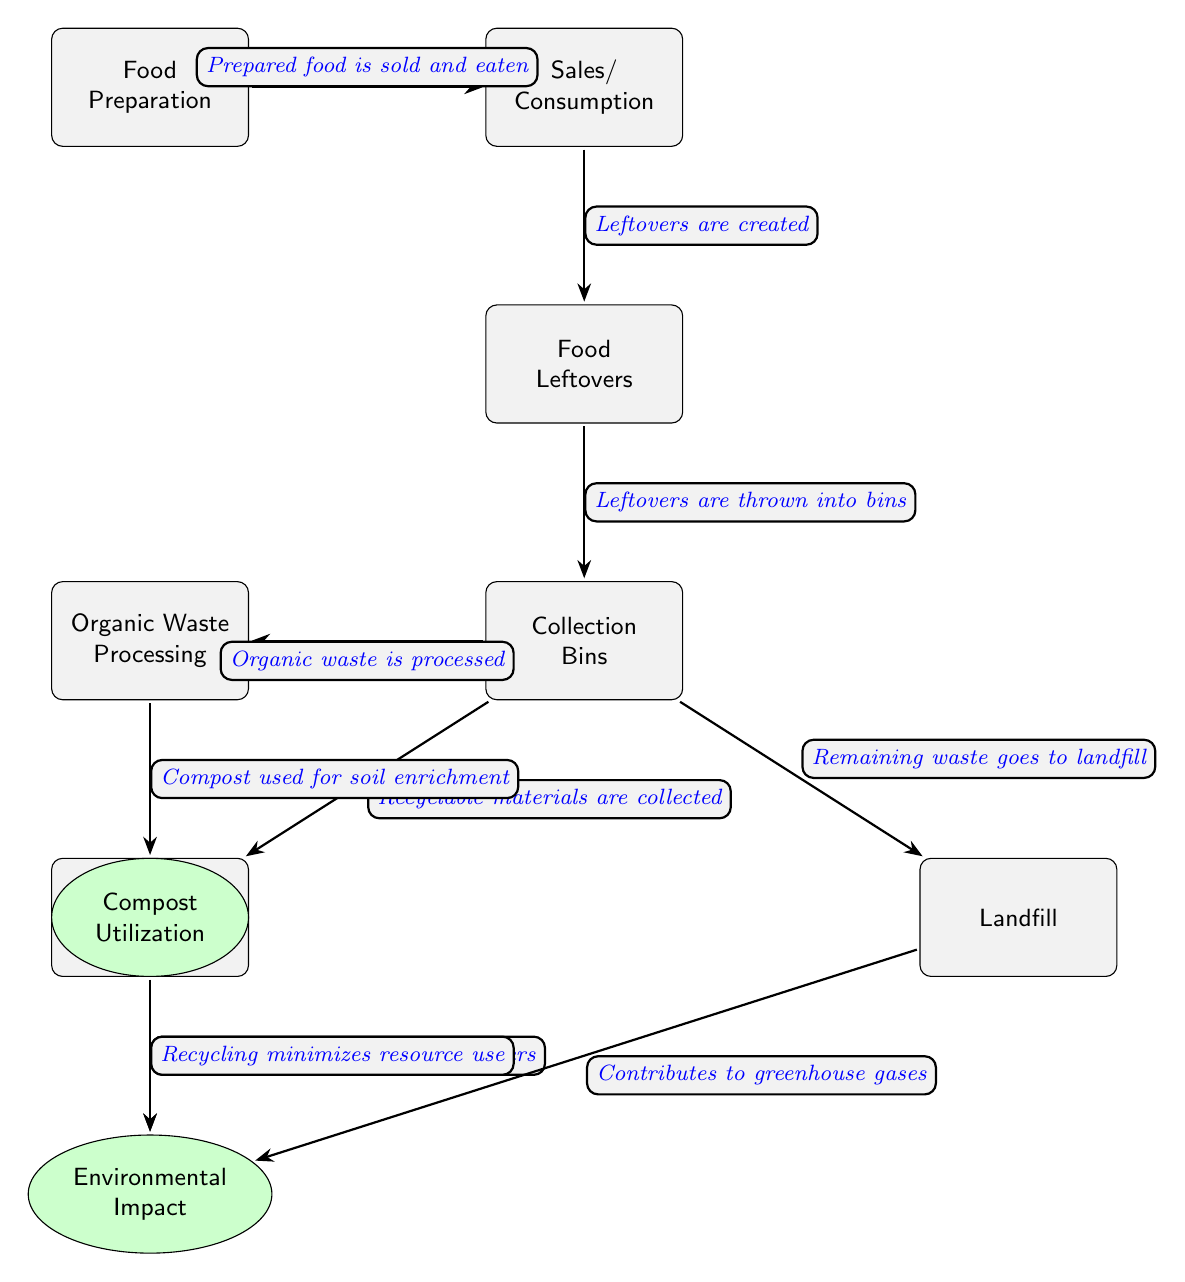What is the first process in the lifecycle of food waste? The diagram shows that the first process is "Food Preparation" which initiates the lifecycle of food waste by preparing food that will be sold and consumed.
Answer: Food Preparation Where do food leftovers go according to the diagram? The diagram indicates that food leftovers are directed to "Collection Bins" after they are created from sales and consumption.
Answer: Collection Bins How many main outcomes are there from the collection bins? The diagram illustrates that there are three main outcomes: "Organic Waste Processing," "Recycling Center," and "Landfill," resulting in three distinct paths from the bins.
Answer: Three What is done with organic waste after it is processed? According to the diagram, processed organic waste is utilized for "Compost Utilization," which helps enrich the soil.
Answer: Compost Utilization What is the environmental impact of waste going to the landfill? The diagram highlights that sending waste to the landfill "Contributes to greenhouse gases," indicating its negative environmental consequences.
Answer: Contributes to greenhouse gases What action occurs after food is sold and consumed? The diagram explains that after food is sold and consumed, "Leftovers are created," which leads to the next step in the lifecycle of food waste.
Answer: Leftovers are created What process minimizes resource use according to the diagram? The diagram states that the "Recycling" process minimizes resource use, highlighting its benefits in waste management.
Answer: Recycling minimizes resource use How does composting benefit the environment? The diagram shows that compost helps by "Reduces need for chemical fertilizers," which benefits the environment through sustainable practices.
Answer: Reduces need for chemical fertilizers 